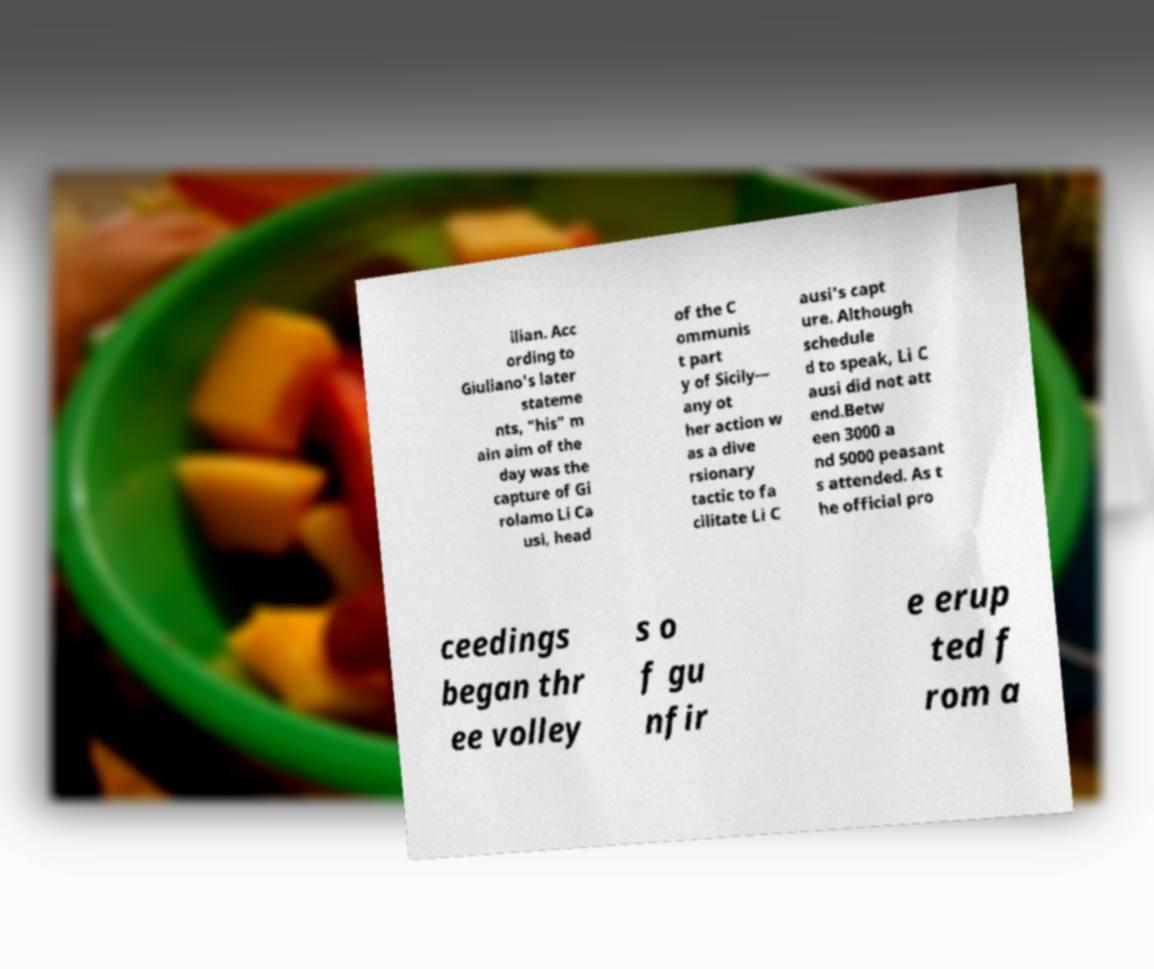Can you accurately transcribe the text from the provided image for me? ilian. Acc ording to Giuliano's later stateme nts, "his" m ain aim of the day was the capture of Gi rolamo Li Ca usi, head of the C ommunis t part y of Sicily— any ot her action w as a dive rsionary tactic to fa cilitate Li C ausi's capt ure. Although schedule d to speak, Li C ausi did not att end.Betw een 3000 a nd 5000 peasant s attended. As t he official pro ceedings began thr ee volley s o f gu nfir e erup ted f rom a 